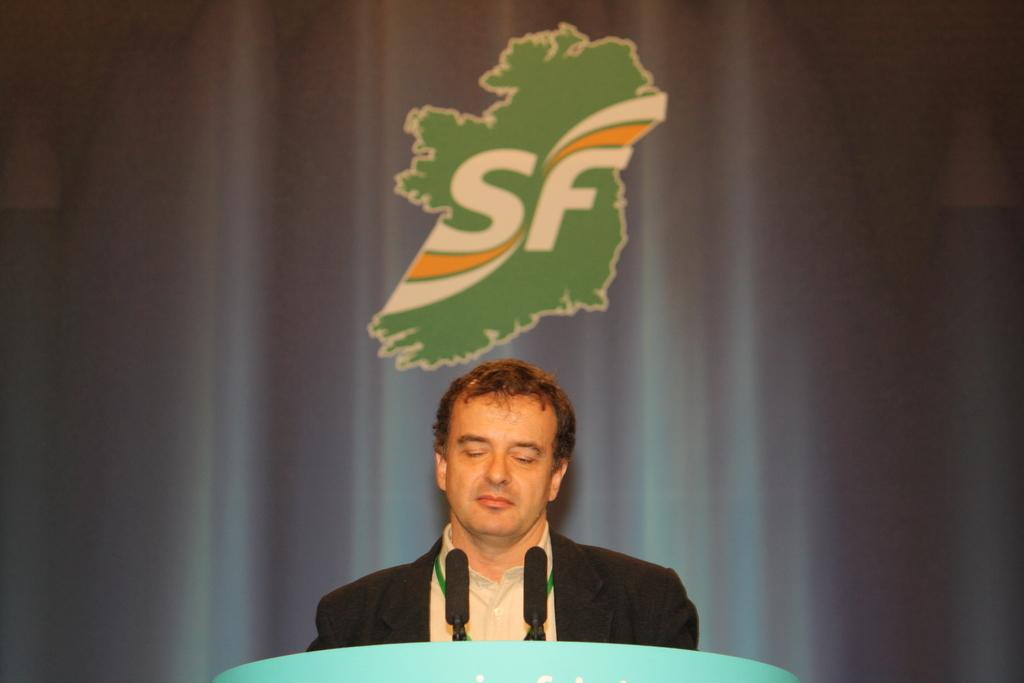Who or what is present in the image? There is a person in the image. What objects can be seen near the person? There are two microphones in the image. What is written or displayed at the top of the image? There is text visible at the top of the image. What can be seen in the background of the image? There is a curtain in the background of the image. Where is the playground located in the image? There is no playground present in the image. Can you tell me the name of the person's brother in the image? There is no mention of a brother or any other person in the image. 